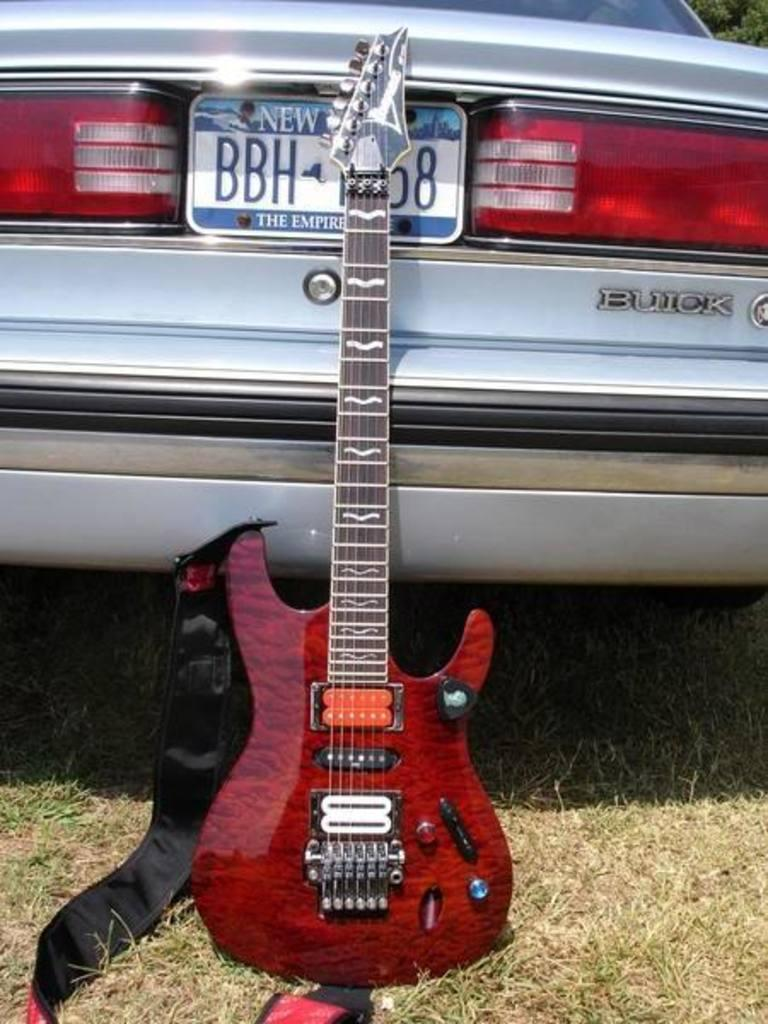What color is the car in the image? The car in the image is silver. What feature is present on the car to identify it? The car has a number plate. What safety feature is present on the car? The car has tail lights. What musical instrument is in the image? There is a red color guitar in the image. What part of the guitar is used to produce sound? The guitar has strings. Where is the guitar placed in the image? The guitar is placed on the grass. How many toys can be seen falling from the sky in the image? There are no toys falling from the sky in the image. Is there a basketball game happening in the image? There is no basketball game or any reference to basketball in the image. 